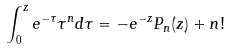<formula> <loc_0><loc_0><loc_500><loc_500>\int _ { 0 } ^ { z } e ^ { - \tau } \tau ^ { n } d \tau = - e ^ { - z } P _ { n } ( z ) + n !</formula> 